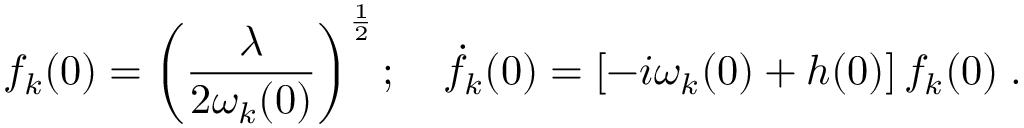<formula> <loc_0><loc_0><loc_500><loc_500>f _ { k } ( 0 ) = \left ( \frac { \lambda } { 2 \omega _ { k } ( 0 ) } \right ) ^ { \frac { 1 } { 2 } } { \dot { f } } _ { k } ( 0 ) = \left [ - i \omega _ { k } ( 0 ) + h ( 0 ) \right ] f _ { k } ( 0 ) \, .</formula> 